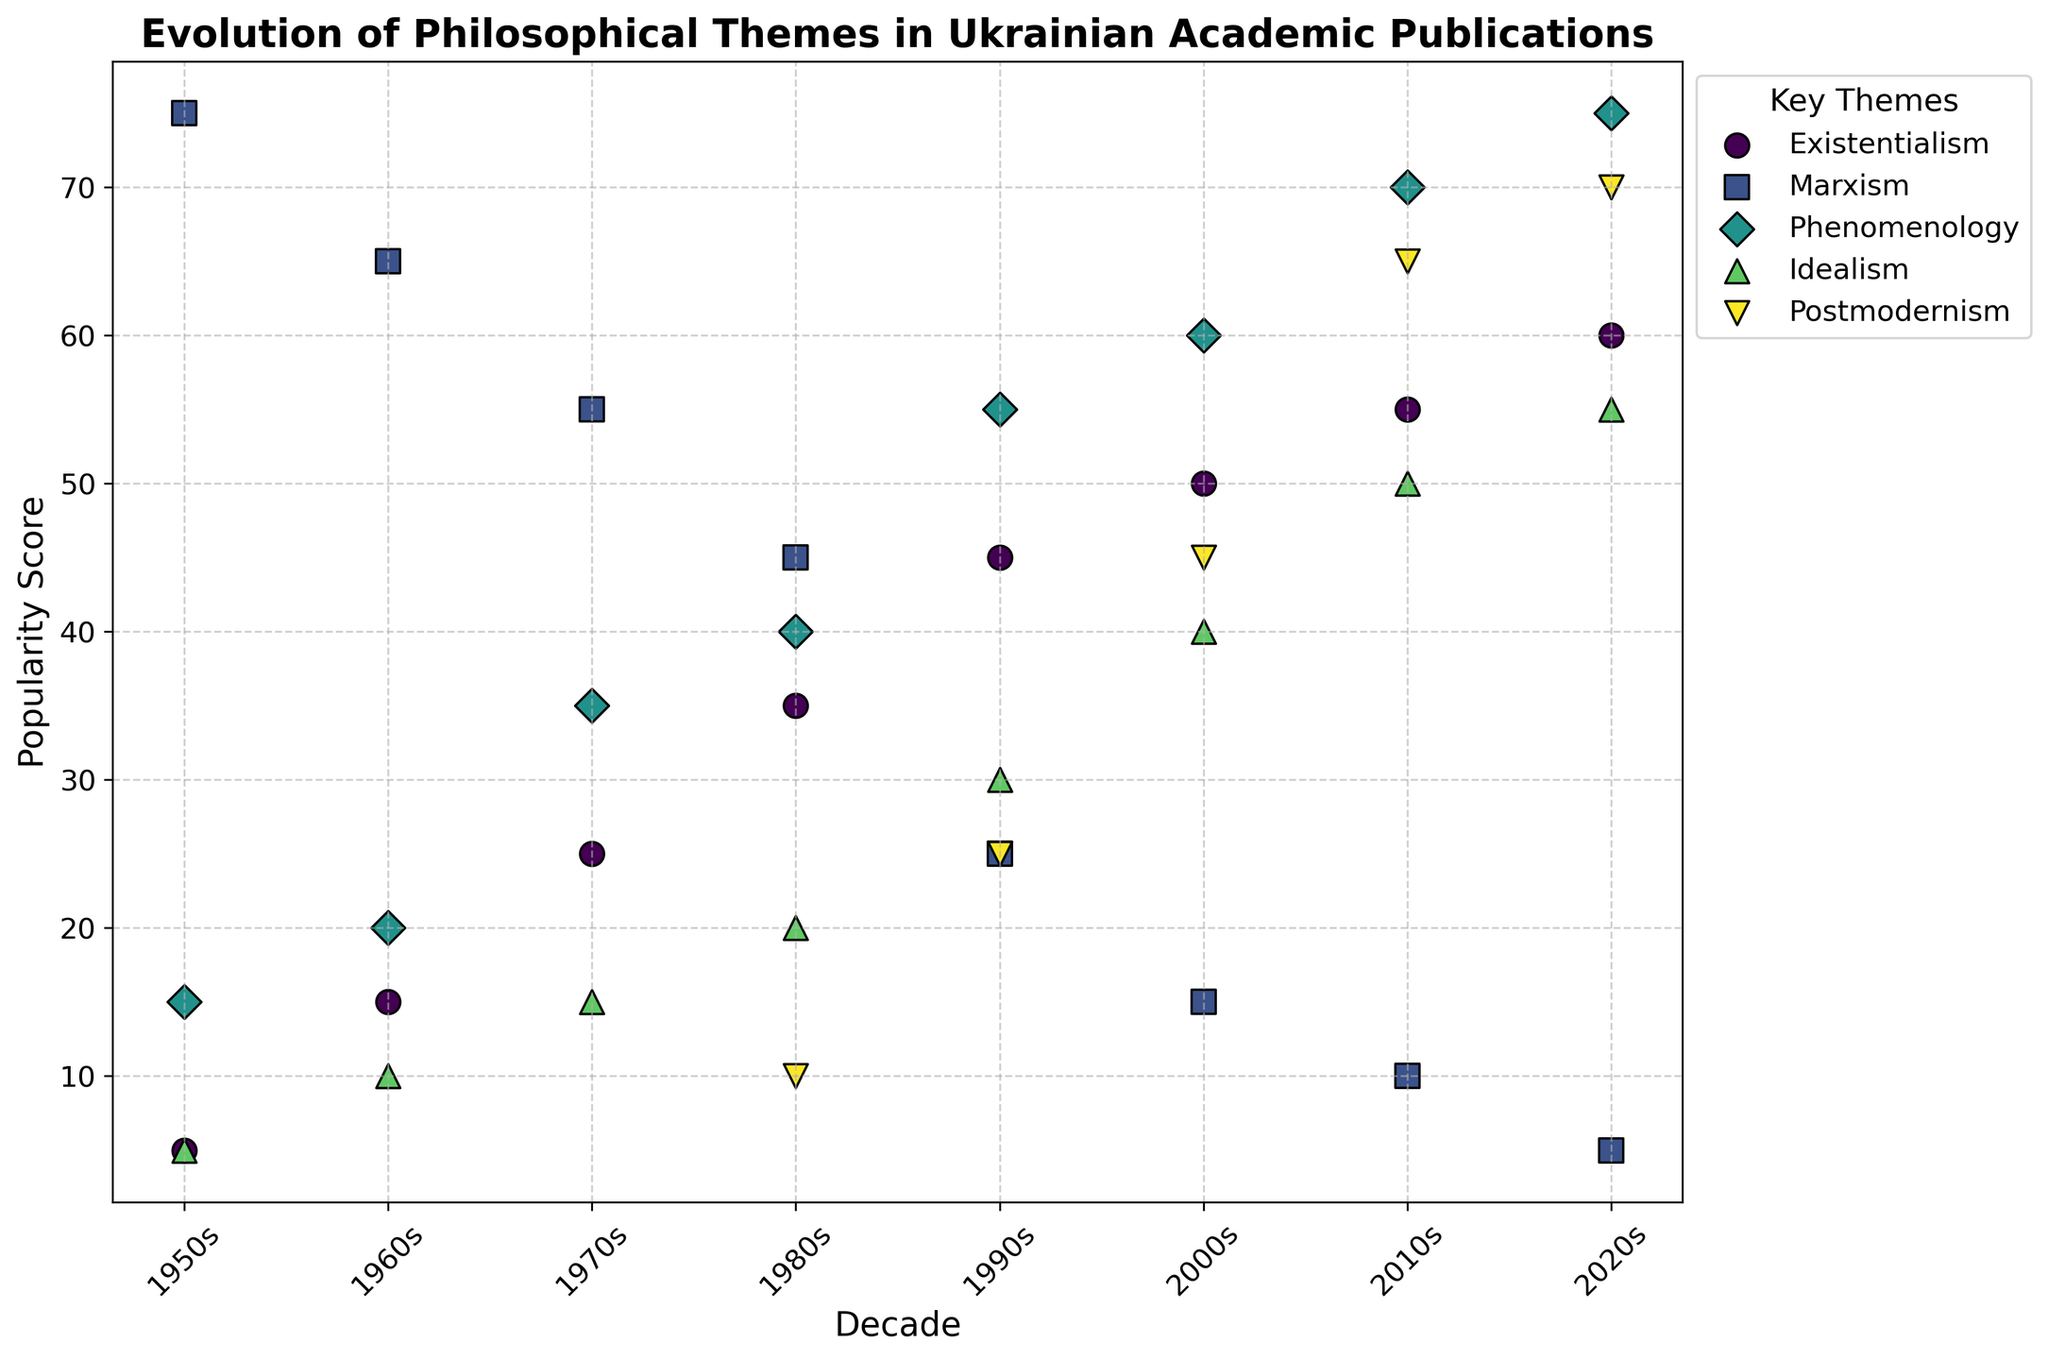Which philosophical theme had the highest popularity score in the 1950s? By looking at the scatter plot for the 1950s, the theme that reaches the highest point (y-axis) is Marxism.
Answer: Marxism How did the popularity score of Existentialism change from the 1950s to the 2020s? Compare the y-axis value (popularity score) of Existentialism across the decades. It started at 5 in the 1950s and increased to 60 in the 2020s.
Answer: Increased by 55 Which decade saw the greatest increase in the popularity score of Phenomenology? Analyze the decade-to-decade change in the y-axis value for Phenomenology. The increase from the 1980s (40) to the 1990s (55) is 15, which is the greatest increase.
Answer: 1990s Compare the popularity scores of Marxism and Idealism in the 1980s. Which was higher? By looking at the data points for the 1980s, Marxism has a popularity score of 45 while Idealism has a score of 20.
Answer: Marxism In which decade did Postmodernism see its first appearance, and what was its popularity score then? By analyzing the plot, Postmodernism first appears in the 1980s with a popularity score of 10.
Answer: 1980s, 10 What is the average popularity score of Existentialism over all the decades? Sum the popularity scores of Existentialism from each decade (1950s: 5, 1960s: 15, 1970s: 25, 1980s: 35, 1990s: 45, 2000s: 50, 2010s: 55, 2020s: 60), which is 290. Divide by the number of decades (8).
Answer: 36.25 Which philosophical theme has the highest popularity score in the 2020s and what is the score? By looking at the points for the 2020s, Phenomenology is at the highest position with a score of 75.
Answer: Phenomenology, 75 Compare the popularity scores of Marxism in the 1950s and the 2020s. By how much has it changed? The score for Marxism in the 1950s is 75 and in the 2020s is 5. The change is 75 - 5 = 70.
Answer: Decreased by 70 Which philosophical theme experienced the most consistent increase in popularity from the 1950s to the 2020s? Look at the trends for each theme. Existentialism consistently increases every decade from 5 in the 1950s to 60 in the 2020s.
Answer: Existentialism 